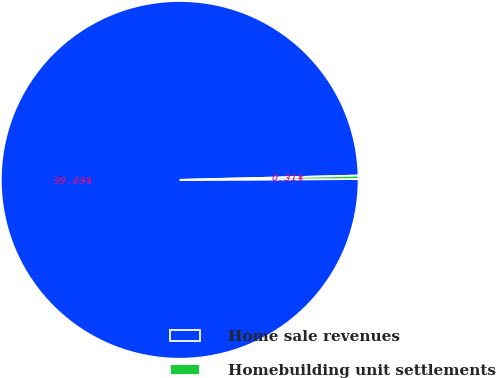Convert chart. <chart><loc_0><loc_0><loc_500><loc_500><pie_chart><fcel>Home sale revenues<fcel>Homebuilding unit settlements<nl><fcel>99.69%<fcel>0.31%<nl></chart> 